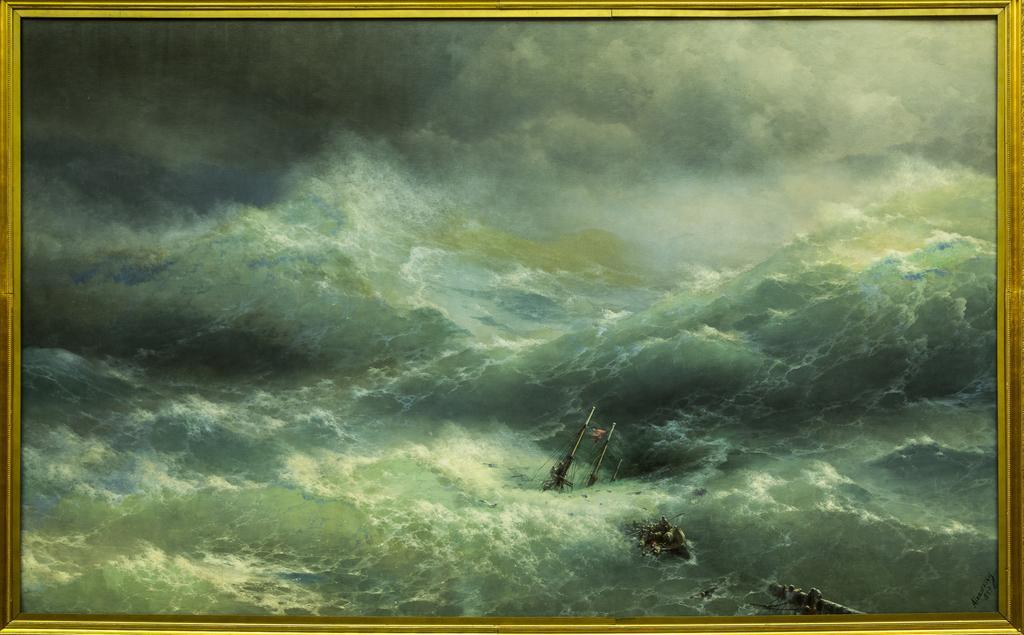Could you give a brief overview of what you see in this image? In this image we can see a frame. In the frame we can see water, few objects, and sky with clouds. 